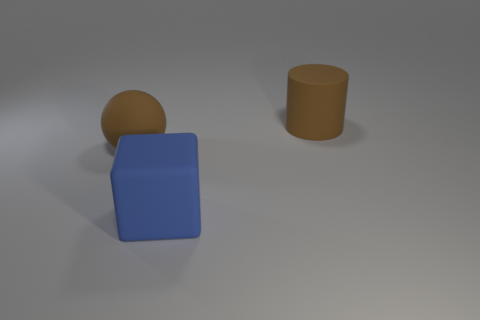What time of day does the lighting in the image suggest? The image features soft, diffused lighting that could suggest an overcast day or a studio setting with ambient lighting, rather than direct sunlight which would cast stronger shadows. 